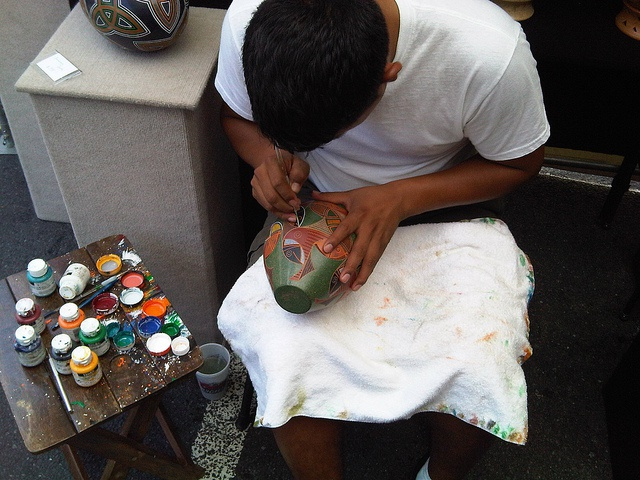Describe the objects in this image and their specific colors. I can see people in gray, black, darkgray, and maroon tones, vase in gray, black, maroon, and brown tones, vase in gray, black, and maroon tones, and cup in gray, black, and darkgray tones in this image. 